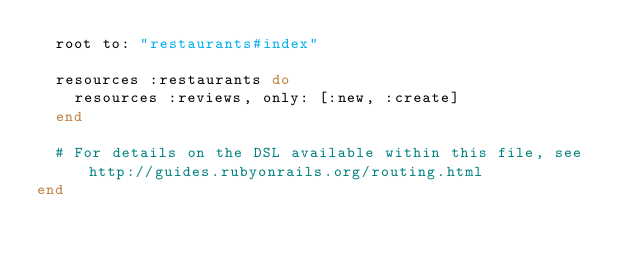Convert code to text. <code><loc_0><loc_0><loc_500><loc_500><_Ruby_>  root to: "restaurants#index"

  resources :restaurants do
    resources :reviews, only: [:new, :create]
  end

  # For details on the DSL available within this file, see http://guides.rubyonrails.org/routing.html
end
</code> 